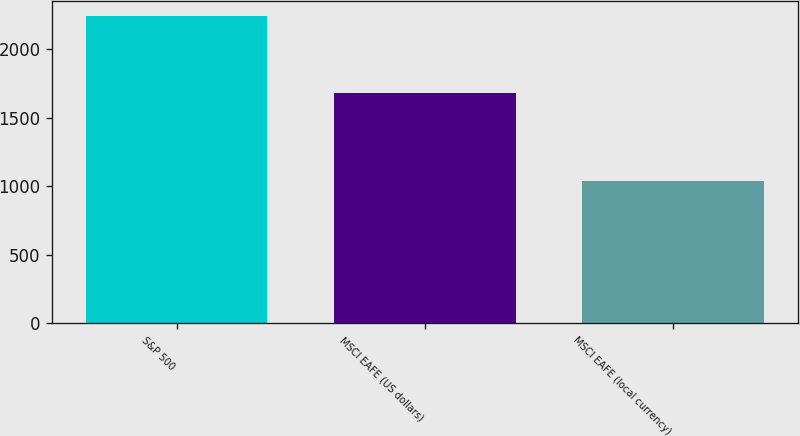<chart> <loc_0><loc_0><loc_500><loc_500><bar_chart><fcel>S&P 500<fcel>MSCI EAFE (US dollars)<fcel>MSCI EAFE (local currency)<nl><fcel>2239<fcel>1684<fcel>1037<nl></chart> 